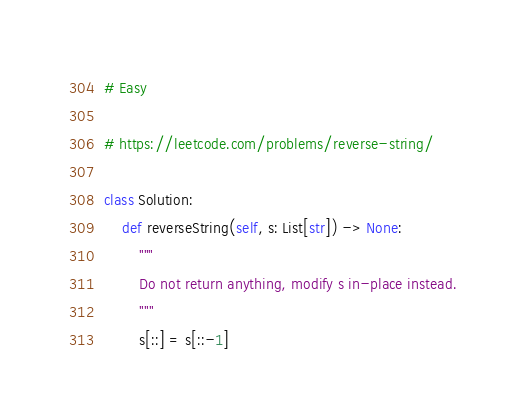<code> <loc_0><loc_0><loc_500><loc_500><_Python_># Easy

# https://leetcode.com/problems/reverse-string/

class Solution:
    def reverseString(self, s: List[str]) -> None:
        """
        Do not return anything, modify s in-place instead.
        """
        s[::] = s[::-1]</code> 